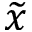Convert formula to latex. <formula><loc_0><loc_0><loc_500><loc_500>\widetilde { x }</formula> 